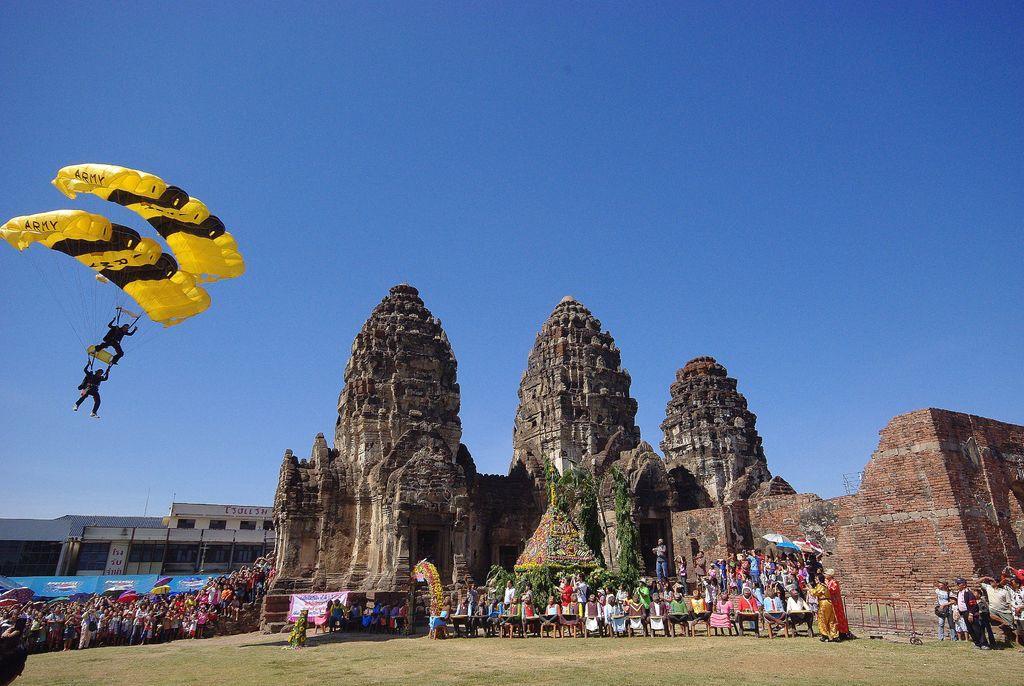Please provide a concise description of this image. At the bottom of the image there is grass. In the middle of the image few people are standing and sitting and holding umbrellas. Behind them there is a fort and building. At the top of the image there is sky. On the left side of the image two persons are doing paragliding. 